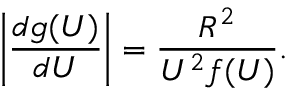<formula> <loc_0><loc_0><loc_500><loc_500>\left | \frac { d g ( U ) } { d U } \right | = \frac { R ^ { 2 } } { U ^ { 2 } f ( U ) } .</formula> 